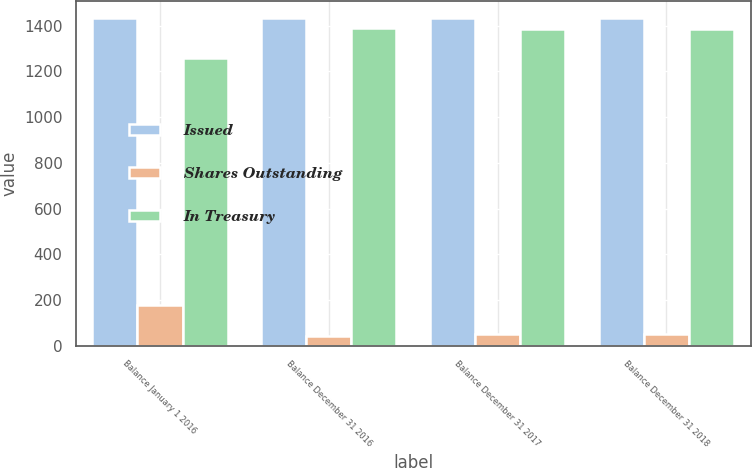Convert chart. <chart><loc_0><loc_0><loc_500><loc_500><stacked_bar_chart><ecel><fcel>Balance January 1 2016<fcel>Balance December 31 2016<fcel>Balance December 31 2017<fcel>Balance December 31 2018<nl><fcel>Issued<fcel>1434<fcel>1434<fcel>1434<fcel>1434<nl><fcel>Shares Outstanding<fcel>178<fcel>43<fcel>50<fcel>51<nl><fcel>In Treasury<fcel>1256<fcel>1391<fcel>1384<fcel>1383<nl></chart> 